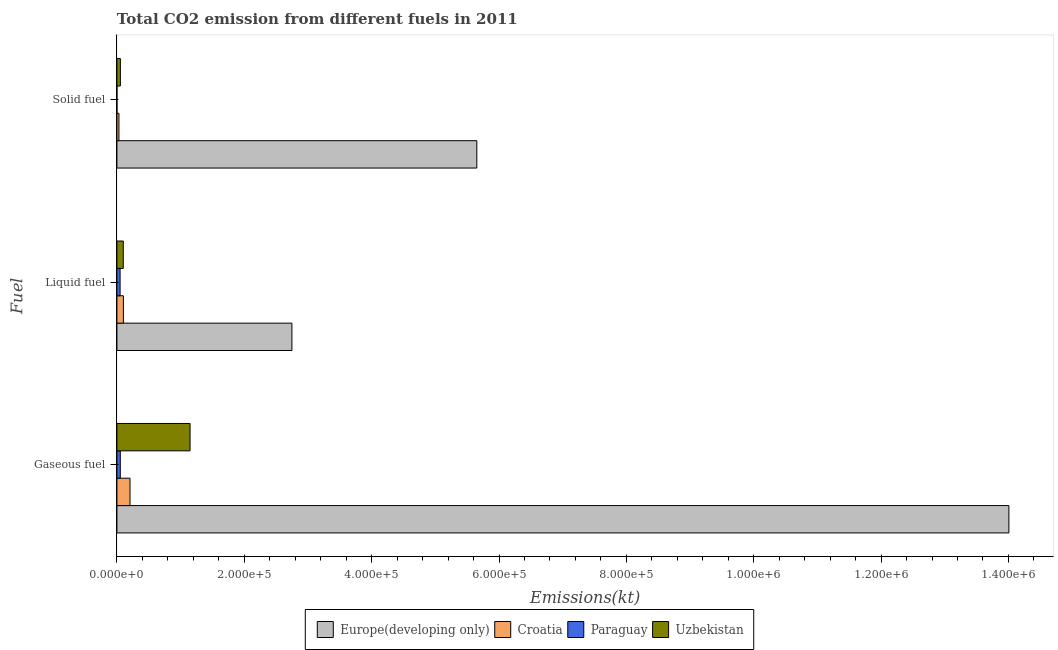How many different coloured bars are there?
Give a very brief answer. 4. How many groups of bars are there?
Keep it short and to the point. 3. Are the number of bars per tick equal to the number of legend labels?
Provide a short and direct response. Yes. What is the label of the 1st group of bars from the top?
Offer a very short reply. Solid fuel. What is the amount of co2 emissions from solid fuel in Uzbekistan?
Your response must be concise. 5419.83. Across all countries, what is the maximum amount of co2 emissions from liquid fuel?
Make the answer very short. 2.75e+05. Across all countries, what is the minimum amount of co2 emissions from liquid fuel?
Give a very brief answer. 4994.45. In which country was the amount of co2 emissions from solid fuel maximum?
Keep it short and to the point. Europe(developing only). In which country was the amount of co2 emissions from liquid fuel minimum?
Your answer should be very brief. Paraguay. What is the total amount of co2 emissions from liquid fuel in the graph?
Your response must be concise. 3.00e+05. What is the difference between the amount of co2 emissions from gaseous fuel in Paraguay and that in Europe(developing only)?
Make the answer very short. -1.40e+06. What is the difference between the amount of co2 emissions from liquid fuel in Europe(developing only) and the amount of co2 emissions from gaseous fuel in Paraguay?
Your response must be concise. 2.69e+05. What is the average amount of co2 emissions from gaseous fuel per country?
Give a very brief answer. 3.85e+05. What is the difference between the amount of co2 emissions from liquid fuel and amount of co2 emissions from solid fuel in Croatia?
Provide a succinct answer. 6985.64. What is the ratio of the amount of co2 emissions from gaseous fuel in Europe(developing only) to that in Croatia?
Provide a succinct answer. 68.15. Is the difference between the amount of co2 emissions from liquid fuel in Europe(developing only) and Uzbekistan greater than the difference between the amount of co2 emissions from gaseous fuel in Europe(developing only) and Uzbekistan?
Provide a short and direct response. No. What is the difference between the highest and the second highest amount of co2 emissions from liquid fuel?
Ensure brevity in your answer.  2.65e+05. What is the difference between the highest and the lowest amount of co2 emissions from gaseous fuel?
Your answer should be compact. 1.40e+06. Is the sum of the amount of co2 emissions from solid fuel in Paraguay and Uzbekistan greater than the maximum amount of co2 emissions from gaseous fuel across all countries?
Ensure brevity in your answer.  No. What does the 4th bar from the top in Gaseous fuel represents?
Your answer should be compact. Europe(developing only). What does the 1st bar from the bottom in Solid fuel represents?
Give a very brief answer. Europe(developing only). Are all the bars in the graph horizontal?
Ensure brevity in your answer.  Yes. What is the difference between two consecutive major ticks on the X-axis?
Your answer should be compact. 2.00e+05. Are the values on the major ticks of X-axis written in scientific E-notation?
Offer a terse response. Yes. Where does the legend appear in the graph?
Offer a very short reply. Bottom center. How are the legend labels stacked?
Offer a very short reply. Horizontal. What is the title of the graph?
Provide a short and direct response. Total CO2 emission from different fuels in 2011. Does "Romania" appear as one of the legend labels in the graph?
Your answer should be compact. No. What is the label or title of the X-axis?
Provide a succinct answer. Emissions(kt). What is the label or title of the Y-axis?
Your answer should be very brief. Fuel. What is the Emissions(kt) of Europe(developing only) in Gaseous fuel?
Keep it short and to the point. 1.40e+06. What is the Emissions(kt) in Croatia in Gaseous fuel?
Your answer should be very brief. 2.06e+04. What is the Emissions(kt) in Paraguay in Gaseous fuel?
Your answer should be very brief. 5298.81. What is the Emissions(kt) in Uzbekistan in Gaseous fuel?
Offer a terse response. 1.15e+05. What is the Emissions(kt) of Europe(developing only) in Liquid fuel?
Ensure brevity in your answer.  2.75e+05. What is the Emissions(kt) in Croatia in Liquid fuel?
Ensure brevity in your answer.  1.02e+04. What is the Emissions(kt) in Paraguay in Liquid fuel?
Make the answer very short. 4994.45. What is the Emissions(kt) of Uzbekistan in Liquid fuel?
Offer a very short reply. 9985.24. What is the Emissions(kt) of Europe(developing only) in Solid fuel?
Make the answer very short. 5.65e+05. What is the Emissions(kt) in Croatia in Solid fuel?
Offer a very short reply. 3168.29. What is the Emissions(kt) in Paraguay in Solid fuel?
Offer a very short reply. 3.67. What is the Emissions(kt) of Uzbekistan in Solid fuel?
Your response must be concise. 5419.83. Across all Fuel, what is the maximum Emissions(kt) in Europe(developing only)?
Your answer should be very brief. 1.40e+06. Across all Fuel, what is the maximum Emissions(kt) of Croatia?
Provide a short and direct response. 2.06e+04. Across all Fuel, what is the maximum Emissions(kt) in Paraguay?
Provide a short and direct response. 5298.81. Across all Fuel, what is the maximum Emissions(kt) of Uzbekistan?
Your response must be concise. 1.15e+05. Across all Fuel, what is the minimum Emissions(kt) in Europe(developing only)?
Your response must be concise. 2.75e+05. Across all Fuel, what is the minimum Emissions(kt) of Croatia?
Offer a terse response. 3168.29. Across all Fuel, what is the minimum Emissions(kt) in Paraguay?
Your response must be concise. 3.67. Across all Fuel, what is the minimum Emissions(kt) of Uzbekistan?
Your answer should be very brief. 5419.83. What is the total Emissions(kt) of Europe(developing only) in the graph?
Offer a very short reply. 2.24e+06. What is the total Emissions(kt) in Croatia in the graph?
Make the answer very short. 3.39e+04. What is the total Emissions(kt) in Paraguay in the graph?
Provide a short and direct response. 1.03e+04. What is the total Emissions(kt) in Uzbekistan in the graph?
Your response must be concise. 1.30e+05. What is the difference between the Emissions(kt) in Europe(developing only) in Gaseous fuel and that in Liquid fuel?
Ensure brevity in your answer.  1.13e+06. What is the difference between the Emissions(kt) in Croatia in Gaseous fuel and that in Liquid fuel?
Ensure brevity in your answer.  1.04e+04. What is the difference between the Emissions(kt) of Paraguay in Gaseous fuel and that in Liquid fuel?
Your response must be concise. 304.36. What is the difference between the Emissions(kt) in Uzbekistan in Gaseous fuel and that in Liquid fuel?
Your response must be concise. 1.05e+05. What is the difference between the Emissions(kt) in Europe(developing only) in Gaseous fuel and that in Solid fuel?
Provide a succinct answer. 8.36e+05. What is the difference between the Emissions(kt) in Croatia in Gaseous fuel and that in Solid fuel?
Your answer should be very brief. 1.74e+04. What is the difference between the Emissions(kt) in Paraguay in Gaseous fuel and that in Solid fuel?
Your response must be concise. 5295.15. What is the difference between the Emissions(kt) of Uzbekistan in Gaseous fuel and that in Solid fuel?
Provide a short and direct response. 1.09e+05. What is the difference between the Emissions(kt) in Europe(developing only) in Liquid fuel and that in Solid fuel?
Keep it short and to the point. -2.90e+05. What is the difference between the Emissions(kt) in Croatia in Liquid fuel and that in Solid fuel?
Your answer should be compact. 6985.64. What is the difference between the Emissions(kt) of Paraguay in Liquid fuel and that in Solid fuel?
Your response must be concise. 4990.79. What is the difference between the Emissions(kt) of Uzbekistan in Liquid fuel and that in Solid fuel?
Your answer should be compact. 4565.41. What is the difference between the Emissions(kt) in Europe(developing only) in Gaseous fuel and the Emissions(kt) in Croatia in Liquid fuel?
Provide a succinct answer. 1.39e+06. What is the difference between the Emissions(kt) of Europe(developing only) in Gaseous fuel and the Emissions(kt) of Paraguay in Liquid fuel?
Provide a short and direct response. 1.40e+06. What is the difference between the Emissions(kt) of Europe(developing only) in Gaseous fuel and the Emissions(kt) of Uzbekistan in Liquid fuel?
Your answer should be very brief. 1.39e+06. What is the difference between the Emissions(kt) of Croatia in Gaseous fuel and the Emissions(kt) of Paraguay in Liquid fuel?
Keep it short and to the point. 1.56e+04. What is the difference between the Emissions(kt) in Croatia in Gaseous fuel and the Emissions(kt) in Uzbekistan in Liquid fuel?
Make the answer very short. 1.06e+04. What is the difference between the Emissions(kt) in Paraguay in Gaseous fuel and the Emissions(kt) in Uzbekistan in Liquid fuel?
Provide a short and direct response. -4686.43. What is the difference between the Emissions(kt) of Europe(developing only) in Gaseous fuel and the Emissions(kt) of Croatia in Solid fuel?
Your response must be concise. 1.40e+06. What is the difference between the Emissions(kt) in Europe(developing only) in Gaseous fuel and the Emissions(kt) in Paraguay in Solid fuel?
Make the answer very short. 1.40e+06. What is the difference between the Emissions(kt) in Europe(developing only) in Gaseous fuel and the Emissions(kt) in Uzbekistan in Solid fuel?
Provide a succinct answer. 1.40e+06. What is the difference between the Emissions(kt) of Croatia in Gaseous fuel and the Emissions(kt) of Paraguay in Solid fuel?
Provide a succinct answer. 2.05e+04. What is the difference between the Emissions(kt) of Croatia in Gaseous fuel and the Emissions(kt) of Uzbekistan in Solid fuel?
Your answer should be very brief. 1.51e+04. What is the difference between the Emissions(kt) of Paraguay in Gaseous fuel and the Emissions(kt) of Uzbekistan in Solid fuel?
Your response must be concise. -121.01. What is the difference between the Emissions(kt) of Europe(developing only) in Liquid fuel and the Emissions(kt) of Croatia in Solid fuel?
Give a very brief answer. 2.72e+05. What is the difference between the Emissions(kt) of Europe(developing only) in Liquid fuel and the Emissions(kt) of Paraguay in Solid fuel?
Offer a terse response. 2.75e+05. What is the difference between the Emissions(kt) of Europe(developing only) in Liquid fuel and the Emissions(kt) of Uzbekistan in Solid fuel?
Offer a very short reply. 2.69e+05. What is the difference between the Emissions(kt) of Croatia in Liquid fuel and the Emissions(kt) of Paraguay in Solid fuel?
Your answer should be very brief. 1.02e+04. What is the difference between the Emissions(kt) in Croatia in Liquid fuel and the Emissions(kt) in Uzbekistan in Solid fuel?
Give a very brief answer. 4734.1. What is the difference between the Emissions(kt) of Paraguay in Liquid fuel and the Emissions(kt) of Uzbekistan in Solid fuel?
Make the answer very short. -425.37. What is the average Emissions(kt) of Europe(developing only) per Fuel?
Your response must be concise. 7.47e+05. What is the average Emissions(kt) of Croatia per Fuel?
Offer a very short reply. 1.13e+04. What is the average Emissions(kt) in Paraguay per Fuel?
Offer a terse response. 3432.31. What is the average Emissions(kt) of Uzbekistan per Fuel?
Offer a very short reply. 4.34e+04. What is the difference between the Emissions(kt) of Europe(developing only) and Emissions(kt) of Croatia in Gaseous fuel?
Offer a terse response. 1.38e+06. What is the difference between the Emissions(kt) in Europe(developing only) and Emissions(kt) in Paraguay in Gaseous fuel?
Offer a terse response. 1.40e+06. What is the difference between the Emissions(kt) of Europe(developing only) and Emissions(kt) of Uzbekistan in Gaseous fuel?
Provide a succinct answer. 1.29e+06. What is the difference between the Emissions(kt) of Croatia and Emissions(kt) of Paraguay in Gaseous fuel?
Your response must be concise. 1.53e+04. What is the difference between the Emissions(kt) in Croatia and Emissions(kt) in Uzbekistan in Gaseous fuel?
Ensure brevity in your answer.  -9.43e+04. What is the difference between the Emissions(kt) in Paraguay and Emissions(kt) in Uzbekistan in Gaseous fuel?
Your response must be concise. -1.10e+05. What is the difference between the Emissions(kt) in Europe(developing only) and Emissions(kt) in Croatia in Liquid fuel?
Provide a short and direct response. 2.65e+05. What is the difference between the Emissions(kt) of Europe(developing only) and Emissions(kt) of Paraguay in Liquid fuel?
Provide a short and direct response. 2.70e+05. What is the difference between the Emissions(kt) of Europe(developing only) and Emissions(kt) of Uzbekistan in Liquid fuel?
Offer a terse response. 2.65e+05. What is the difference between the Emissions(kt) of Croatia and Emissions(kt) of Paraguay in Liquid fuel?
Make the answer very short. 5159.47. What is the difference between the Emissions(kt) of Croatia and Emissions(kt) of Uzbekistan in Liquid fuel?
Provide a short and direct response. 168.68. What is the difference between the Emissions(kt) in Paraguay and Emissions(kt) in Uzbekistan in Liquid fuel?
Your answer should be very brief. -4990.79. What is the difference between the Emissions(kt) in Europe(developing only) and Emissions(kt) in Croatia in Solid fuel?
Offer a terse response. 5.62e+05. What is the difference between the Emissions(kt) in Europe(developing only) and Emissions(kt) in Paraguay in Solid fuel?
Keep it short and to the point. 5.65e+05. What is the difference between the Emissions(kt) in Europe(developing only) and Emissions(kt) in Uzbekistan in Solid fuel?
Offer a terse response. 5.60e+05. What is the difference between the Emissions(kt) of Croatia and Emissions(kt) of Paraguay in Solid fuel?
Provide a short and direct response. 3164.62. What is the difference between the Emissions(kt) in Croatia and Emissions(kt) in Uzbekistan in Solid fuel?
Provide a short and direct response. -2251.54. What is the difference between the Emissions(kt) in Paraguay and Emissions(kt) in Uzbekistan in Solid fuel?
Offer a terse response. -5416.16. What is the ratio of the Emissions(kt) in Europe(developing only) in Gaseous fuel to that in Liquid fuel?
Ensure brevity in your answer.  5.1. What is the ratio of the Emissions(kt) of Croatia in Gaseous fuel to that in Liquid fuel?
Offer a very short reply. 2.02. What is the ratio of the Emissions(kt) of Paraguay in Gaseous fuel to that in Liquid fuel?
Make the answer very short. 1.06. What is the ratio of the Emissions(kt) in Uzbekistan in Gaseous fuel to that in Liquid fuel?
Give a very brief answer. 11.5. What is the ratio of the Emissions(kt) in Europe(developing only) in Gaseous fuel to that in Solid fuel?
Give a very brief answer. 2.48. What is the ratio of the Emissions(kt) in Croatia in Gaseous fuel to that in Solid fuel?
Offer a terse response. 6.49. What is the ratio of the Emissions(kt) in Paraguay in Gaseous fuel to that in Solid fuel?
Ensure brevity in your answer.  1445. What is the ratio of the Emissions(kt) in Uzbekistan in Gaseous fuel to that in Solid fuel?
Give a very brief answer. 21.19. What is the ratio of the Emissions(kt) of Europe(developing only) in Liquid fuel to that in Solid fuel?
Your response must be concise. 0.49. What is the ratio of the Emissions(kt) of Croatia in Liquid fuel to that in Solid fuel?
Offer a terse response. 3.2. What is the ratio of the Emissions(kt) in Paraguay in Liquid fuel to that in Solid fuel?
Give a very brief answer. 1362. What is the ratio of the Emissions(kt) of Uzbekistan in Liquid fuel to that in Solid fuel?
Ensure brevity in your answer.  1.84. What is the difference between the highest and the second highest Emissions(kt) in Europe(developing only)?
Offer a terse response. 8.36e+05. What is the difference between the highest and the second highest Emissions(kt) in Croatia?
Ensure brevity in your answer.  1.04e+04. What is the difference between the highest and the second highest Emissions(kt) of Paraguay?
Keep it short and to the point. 304.36. What is the difference between the highest and the second highest Emissions(kt) in Uzbekistan?
Offer a very short reply. 1.05e+05. What is the difference between the highest and the lowest Emissions(kt) of Europe(developing only)?
Offer a terse response. 1.13e+06. What is the difference between the highest and the lowest Emissions(kt) in Croatia?
Keep it short and to the point. 1.74e+04. What is the difference between the highest and the lowest Emissions(kt) of Paraguay?
Your response must be concise. 5295.15. What is the difference between the highest and the lowest Emissions(kt) of Uzbekistan?
Your response must be concise. 1.09e+05. 